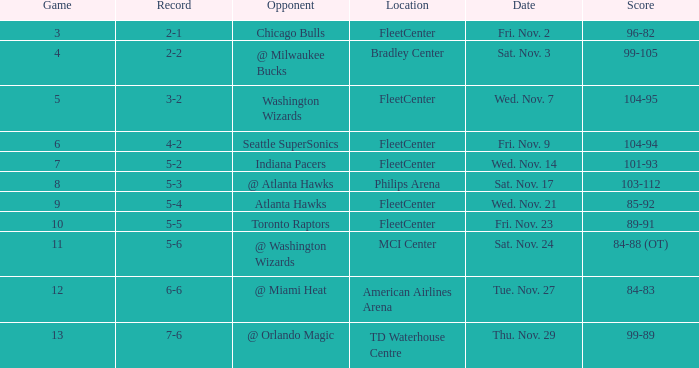Would you be able to parse every entry in this table? {'header': ['Game', 'Record', 'Opponent', 'Location', 'Date', 'Score'], 'rows': [['3', '2-1', 'Chicago Bulls', 'FleetCenter', 'Fri. Nov. 2', '96-82'], ['4', '2-2', '@ Milwaukee Bucks', 'Bradley Center', 'Sat. Nov. 3', '99-105'], ['5', '3-2', 'Washington Wizards', 'FleetCenter', 'Wed. Nov. 7', '104-95'], ['6', '4-2', 'Seattle SuperSonics', 'FleetCenter', 'Fri. Nov. 9', '104-94'], ['7', '5-2', 'Indiana Pacers', 'FleetCenter', 'Wed. Nov. 14', '101-93'], ['8', '5-3', '@ Atlanta Hawks', 'Philips Arena', 'Sat. Nov. 17', '103-112'], ['9', '5-4', 'Atlanta Hawks', 'FleetCenter', 'Wed. Nov. 21', '85-92'], ['10', '5-5', 'Toronto Raptors', 'FleetCenter', 'Fri. Nov. 23', '89-91'], ['11', '5-6', '@ Washington Wizards', 'MCI Center', 'Sat. Nov. 24', '84-88 (OT)'], ['12', '6-6', '@ Miami Heat', 'American Airlines Arena', 'Tue. Nov. 27', '84-83'], ['13', '7-6', '@ Orlando Magic', 'TD Waterhouse Centre', 'Thu. Nov. 29', '99-89']]} Which opponent has a score of 84-88 (ot)? @ Washington Wizards. 